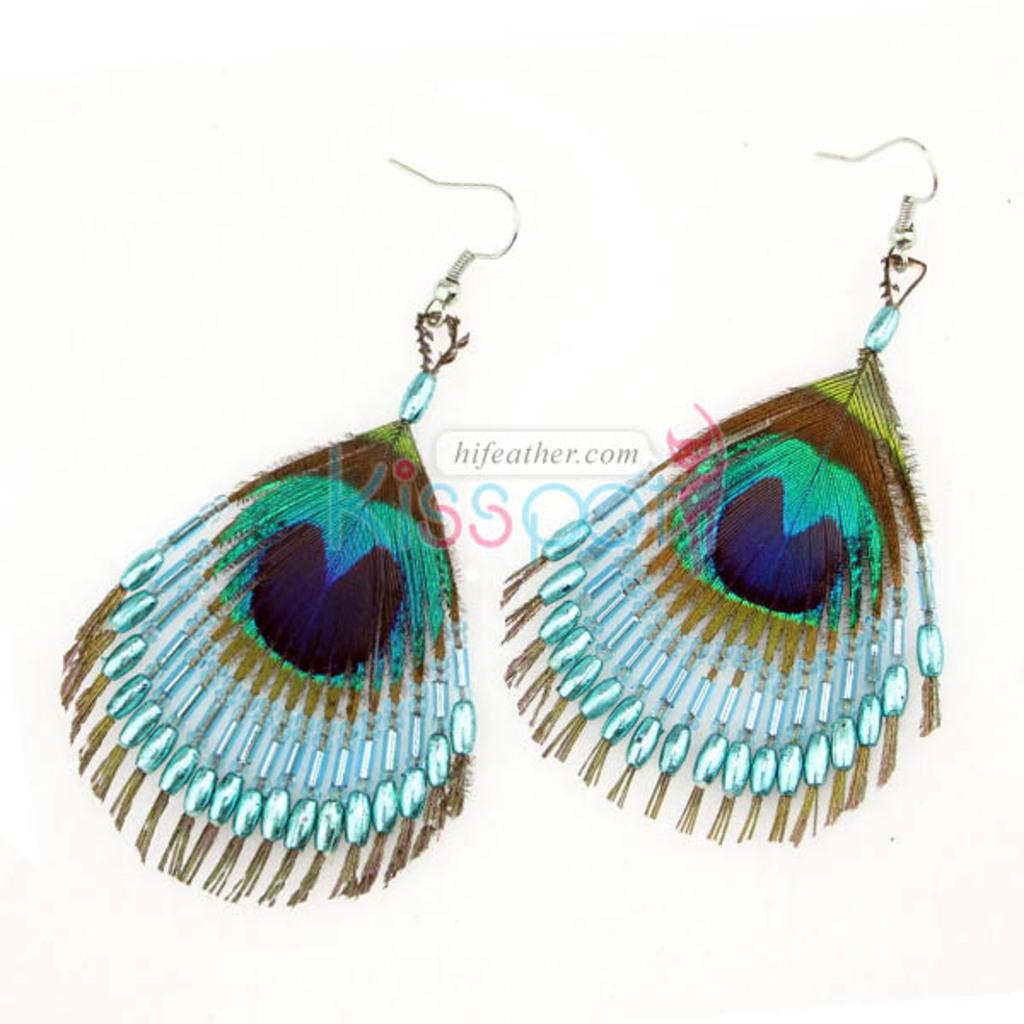What is the main subject in the center of the image? There are earrings in the center of the image. What color is the background of the image? The background of the image is white. What else is present in the center of the image besides the earrings? There is text in the center of the image. What type of bomb is depicted in the image? There is no bomb present in the image; it features earrings and text on a white background. How does the skin of the person wearing the earrings look in the image? There is no person wearing the earrings in the image, so their skin cannot be observed. 